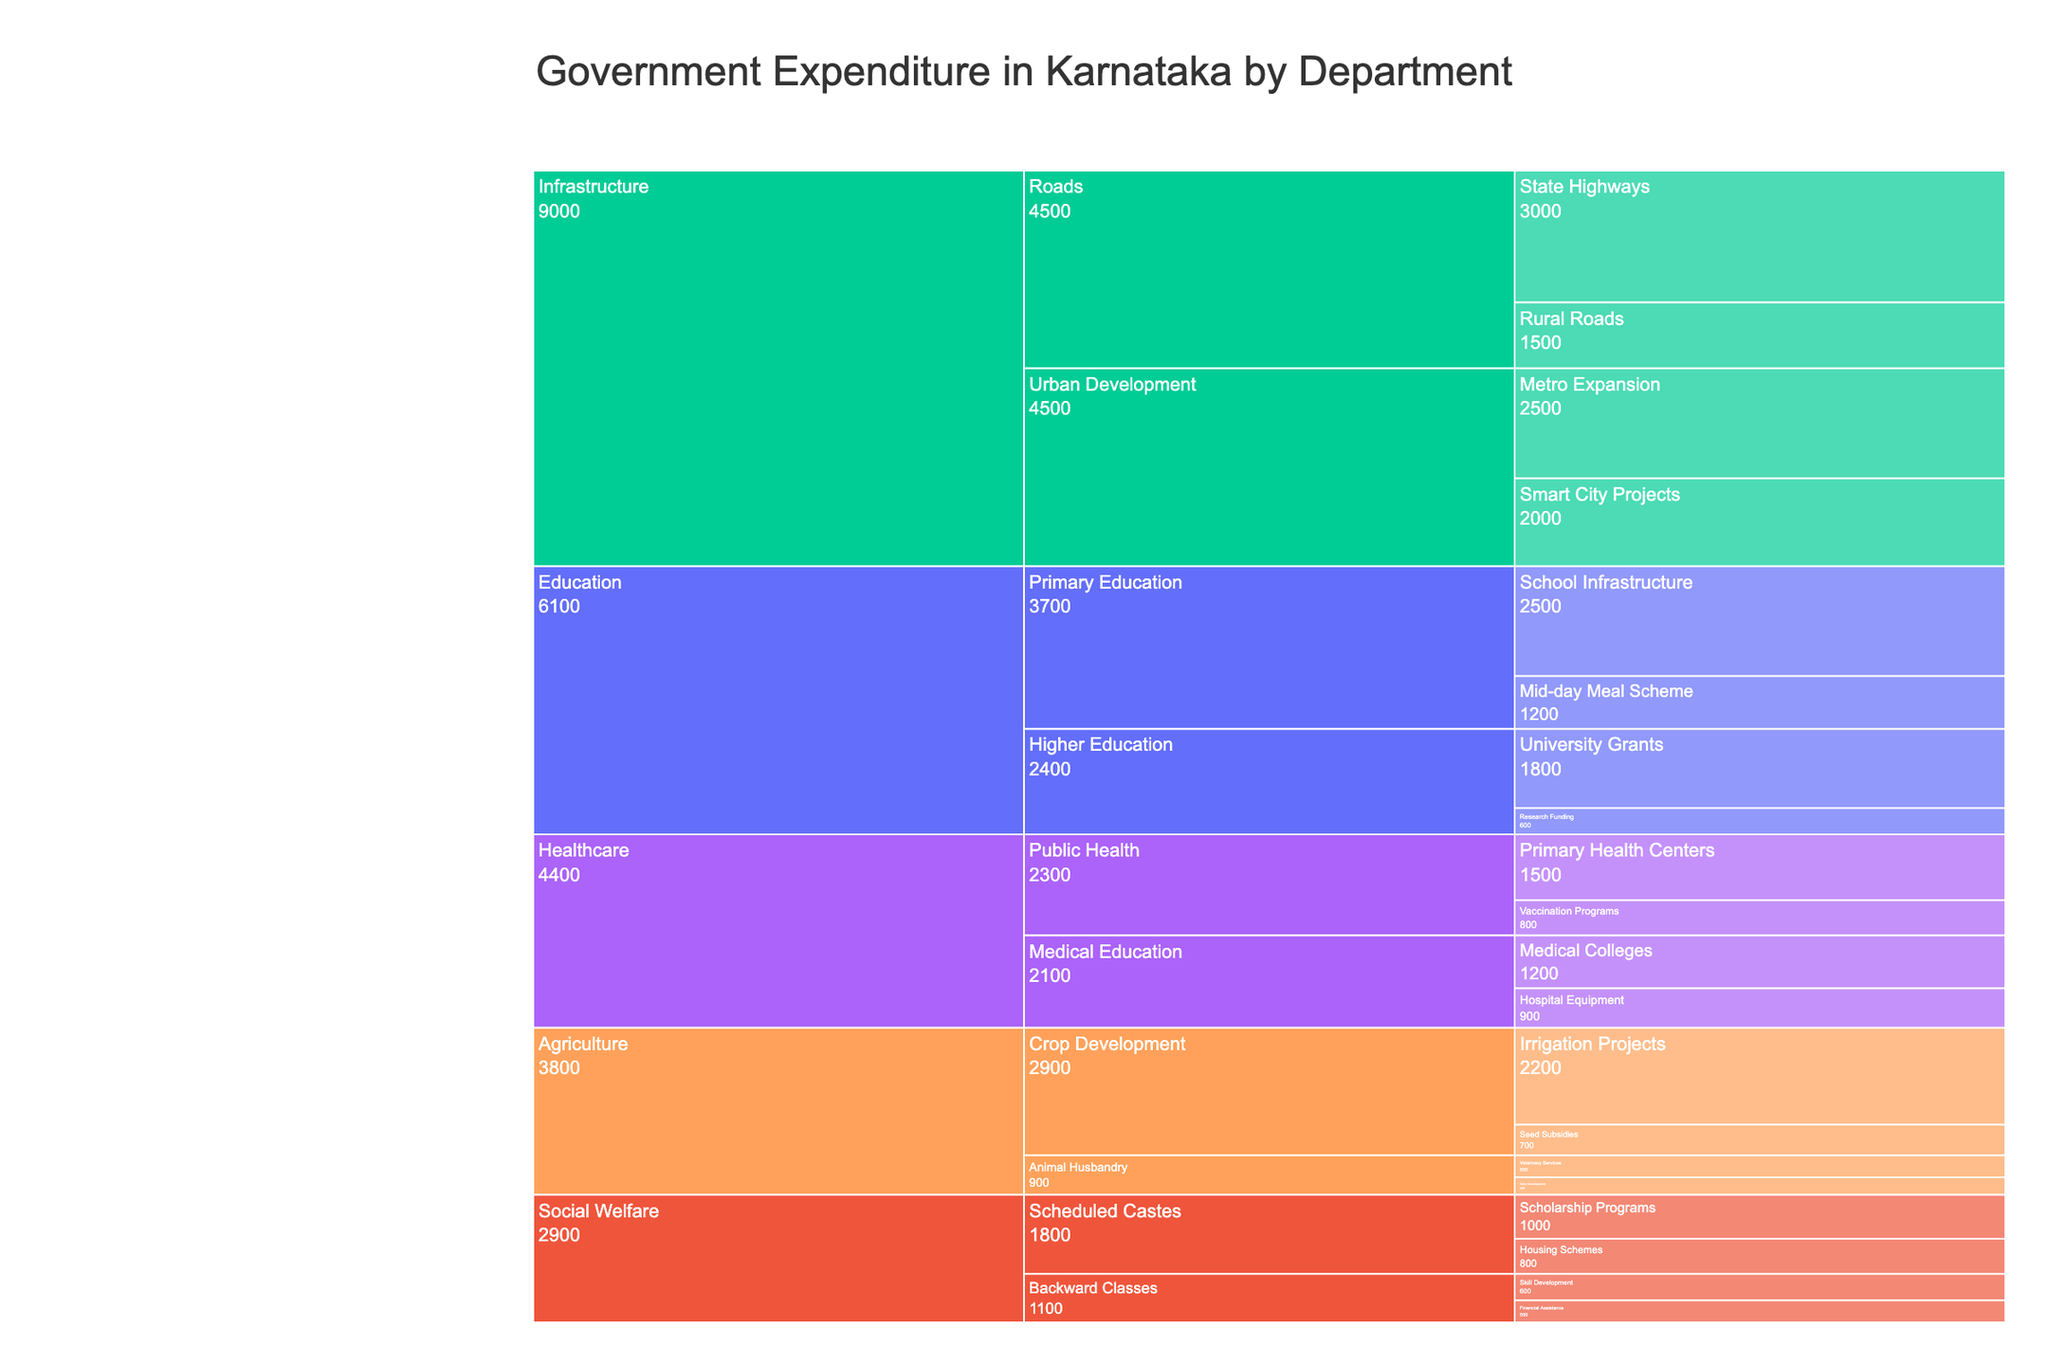What's the department with the highest expenditure? The Icicle Chart displays different departments along with their expenditure. The department with the largest segment is Infrastructure, which shows the highest expenditure.
Answer: Infrastructure Among subcategories, which one has the least expenditure? Each subcategory's expenditure is displayed in the Icicle Chart. The subcategory "Dairy Development" under the Agriculture department has the smallest segment, indicating the lowest expenditure of ₹400 Crores.
Answer: Dairy Development Compare the expenditure on "University Grants" and "Metro Expansion". Which one is greater? Navigate the Icicle Chart to the respective subcategories under "Higher Education" and "Urban Development". "Metro Expansion" has an expenditure of ₹2500 Crores, while "University Grants" has ₹1800 Crores. Therefore, "Metro Expansion" is greater.
Answer: Metro Expansion What's the total expenditure in the Healthcare department? Sum the expenditure of all subcategories under the Healthcare department: Primary Health Centers (₹1500 Crores) + Vaccination Programs (₹800 Crores) + Medical Colleges (₹1200 Crores) + Hospital Equipment (₹900 Crores). The total is ₹4400 Crores.
Answer: ₹4400 Crores What's the difference between the expenditure on "Scheduled Castes" and "Backward Classes" under the Social Welfare department? Calculate the total expenditure for Scheduled Castes (Scholarship Programs: ₹1000 Crores + Housing Schemes: ₹800 Crores = ₹1800 Crores) and Backward Classes (Skill Development: ₹600 Crores + Financial Assistance: ₹500 Crores = ₹1100 Crores). The difference is ₹1800 Crores - ₹1100 Crores = ₹700 Crores.
Answer: ₹700 Crores Which has more expenditure: "Irrigation Projects" in Agriculture or "Smart City Projects" in Infrastructure? Locate the relevant subcategories. "Irrigation Projects" has an expenditure of ₹2200 Crores, while "Smart City Projects" has ₹2000 Crores. Therefore, "Irrigation Projects" has more expenditure.
Answer: Irrigation Projects What’s the average expenditure for subcategories under Primary Education? Calculate the average by summing the expenditures under Primary Education and dividing by the number of subcategories: (School Infrastructure: ₹2500 Crores + Mid-day Meal Scheme: ₹1200 Crores) / 2. The average is ₹3700 Crores / 2 = ₹1850 Crores.
Answer: ₹1850 Crores Identify the category in Education with the least expenditure. In the Education department, compare the nodes under Primary Education and Higher Education. "Research Funding" under Higher Education has the least expenditure of ₹600 Crores.
Answer: Research Funding Which category in Social Welfare has a higher total expenditure, Scheduled Castes or Backward Classes? Calculate total expenditures: Scheduled Castes (Scholarship Programs: ₹1000 Crores + Housing Schemes: ₹800 Crores = ₹1800 Crores) and Backward Classes (Skill Development: ₹600 Crores + Financial Assistance: ₹500 Crores = ₹1100 Crores). Scheduled Castes has higher total expenditure.
Answer: Scheduled Castes What’s the combined expenditure of all subcategories under Roads? Sum the expenditures of "State Highways" and "Rural Roads" under Roads: ₹3000 Crores (State Highways) + ₹1500 Crores (Rural Roads) = ₹4500 Crores.
Answer: ₹4500 Crores 